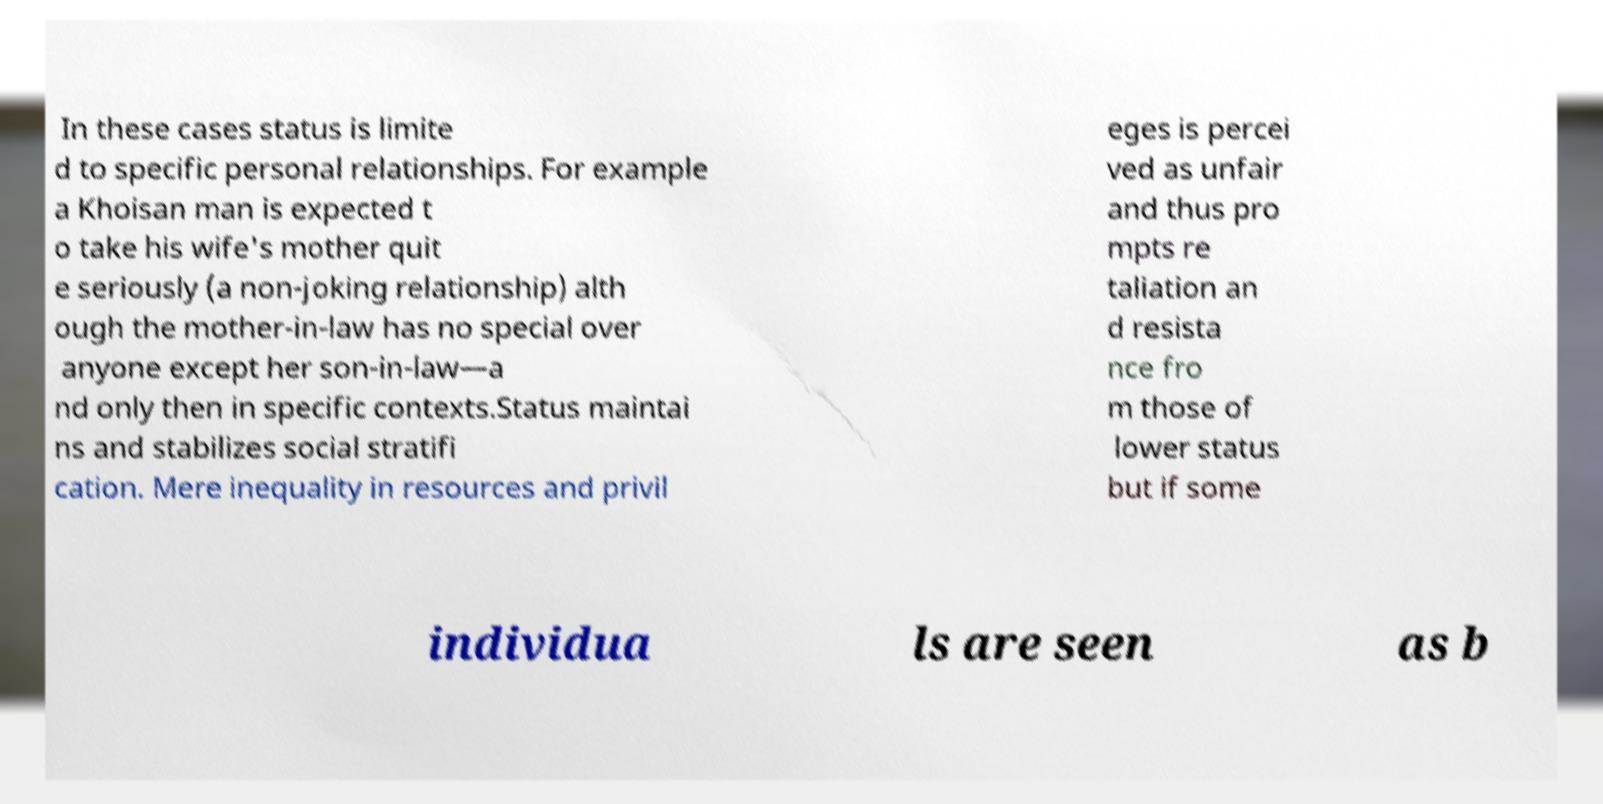I need the written content from this picture converted into text. Can you do that? In these cases status is limite d to specific personal relationships. For example a Khoisan man is expected t o take his wife's mother quit e seriously (a non-joking relationship) alth ough the mother-in-law has no special over anyone except her son-in-law—a nd only then in specific contexts.Status maintai ns and stabilizes social stratifi cation. Mere inequality in resources and privil eges is percei ved as unfair and thus pro mpts re taliation an d resista nce fro m those of lower status but if some individua ls are seen as b 